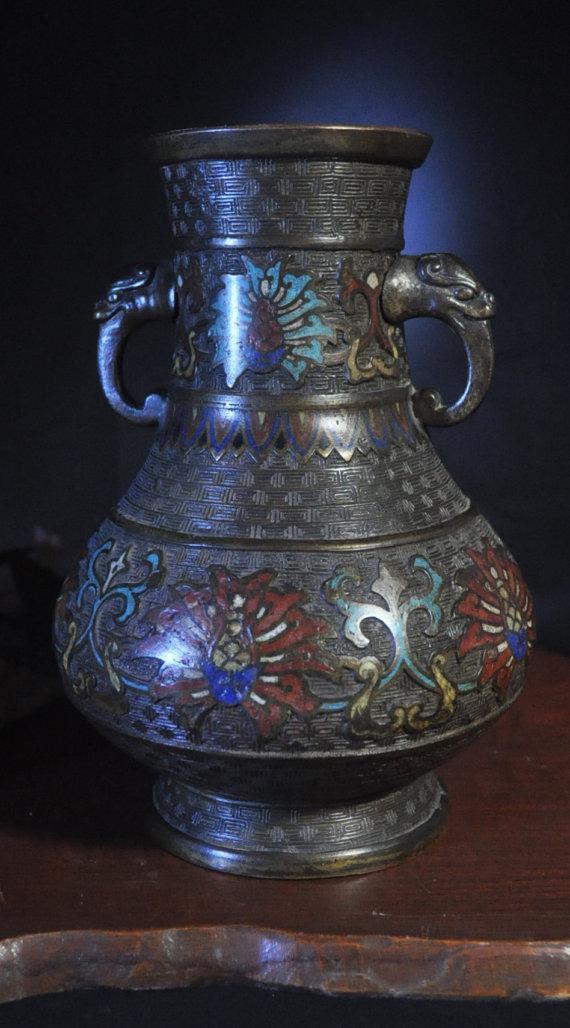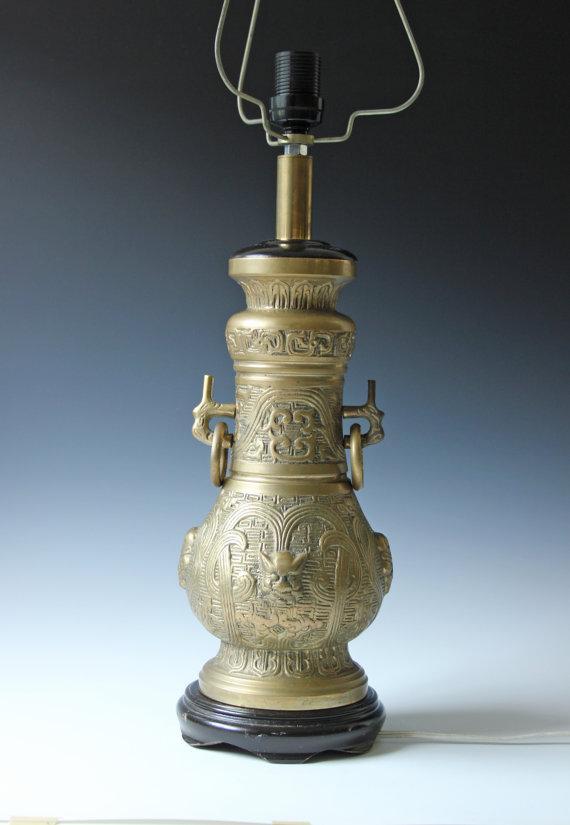The first image is the image on the left, the second image is the image on the right. For the images shown, is this caption "There are side handles on the vase." true? Answer yes or no. Yes. 